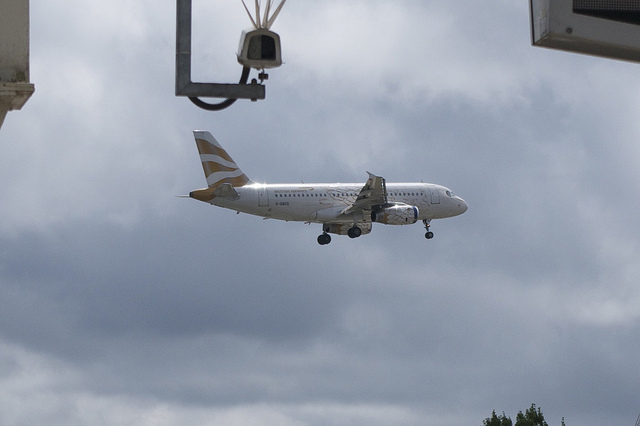<image>Is the plane landing? I don't know if the plane is landing. The answers are conflicting. Is the plane landing? I am not sure if the plane is landing. It can be both landing or not landing. 